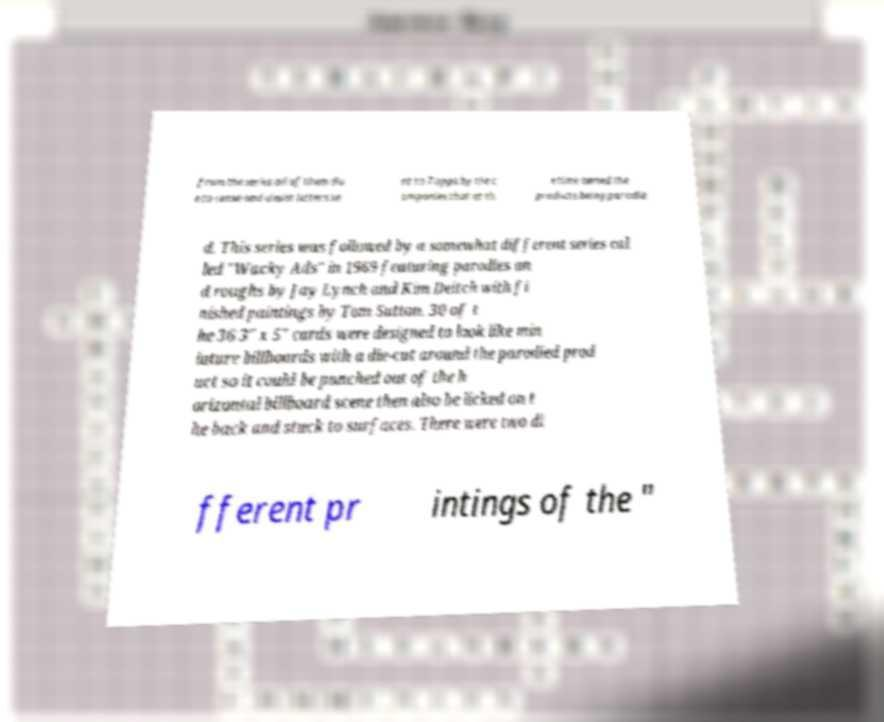Can you read and provide the text displayed in the image?This photo seems to have some interesting text. Can you extract and type it out for me? from the series all of them du e to cease-and-desist letters se nt to Topps by the c ompanies that at th e time owned the products being parodie d. This series was followed by a somewhat different series cal led "Wacky Ads" in 1969 featuring parodies an d roughs by Jay Lynch and Kim Deitch with fi nished paintings by Tom Sutton. 30 of t he 36 3" x 5" cards were designed to look like min iature billboards with a die-cut around the parodied prod uct so it could be punched out of the h orizontal billboard scene then also be licked on t he back and stuck to surfaces. There were two di fferent pr intings of the " 